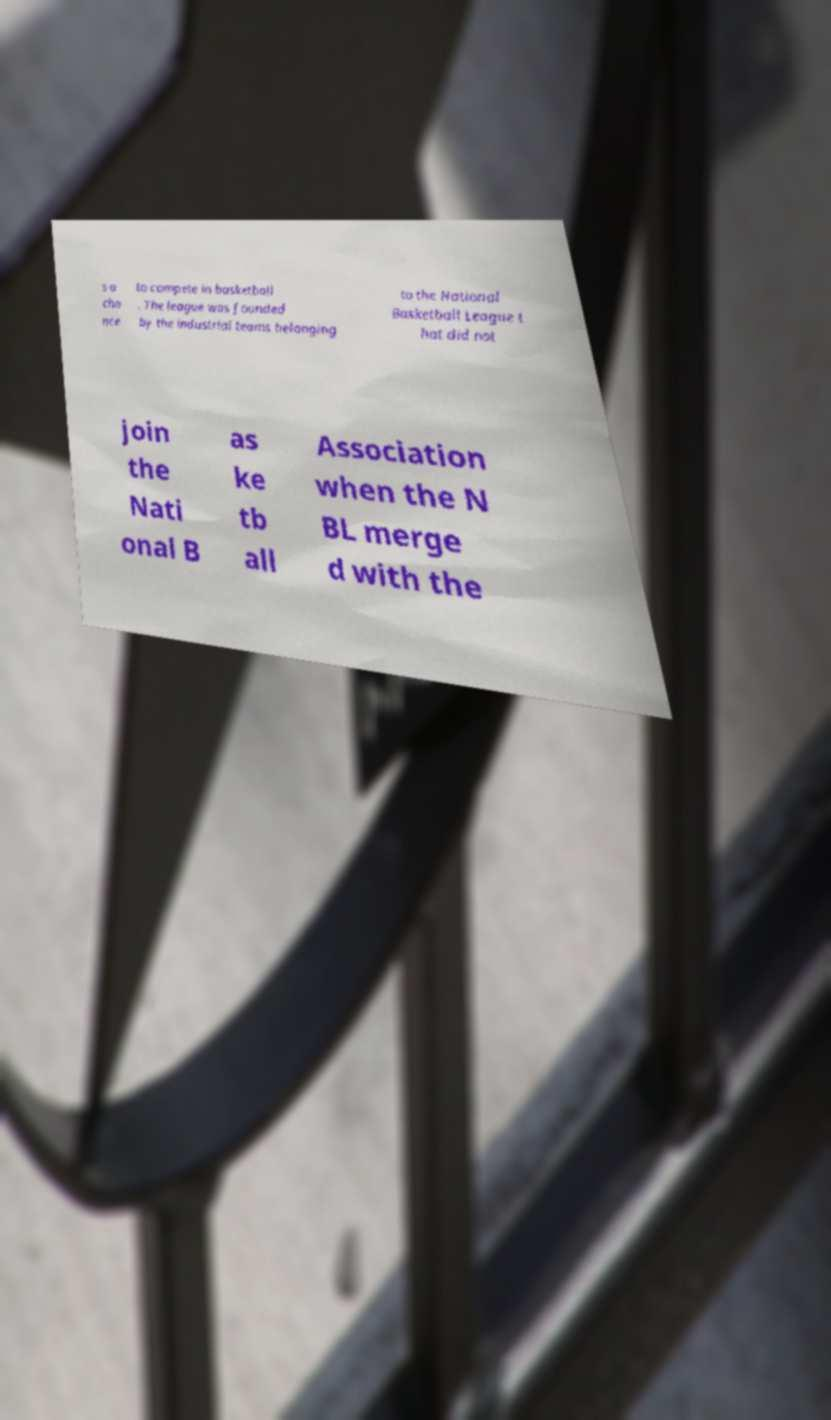Please identify and transcribe the text found in this image. s a cha nce to compete in basketball . The league was founded by the industrial teams belonging to the National Basketball League t hat did not join the Nati onal B as ke tb all Association when the N BL merge d with the 